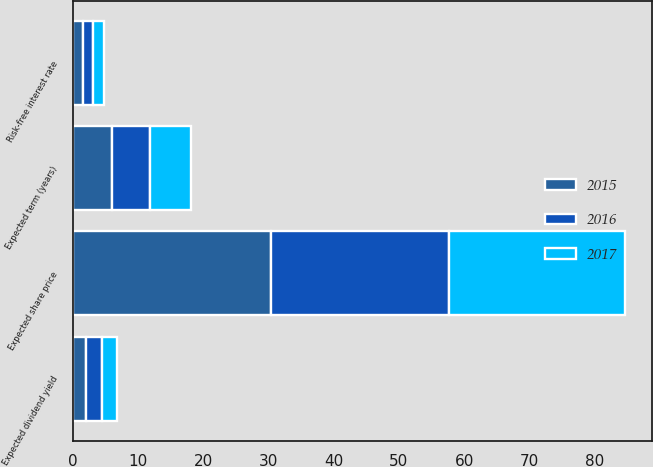Convert chart. <chart><loc_0><loc_0><loc_500><loc_500><stacked_bar_chart><ecel><fcel>Risk-free interest rate<fcel>Expected dividend yield<fcel>Expected share price<fcel>Expected term (years)<nl><fcel>2017<fcel>1.65<fcel>2.35<fcel>26.9<fcel>6.3<nl><fcel>2016<fcel>1.56<fcel>2.49<fcel>27.3<fcel>5.9<nl><fcel>2015<fcel>1.6<fcel>1.97<fcel>30.4<fcel>6<nl></chart> 